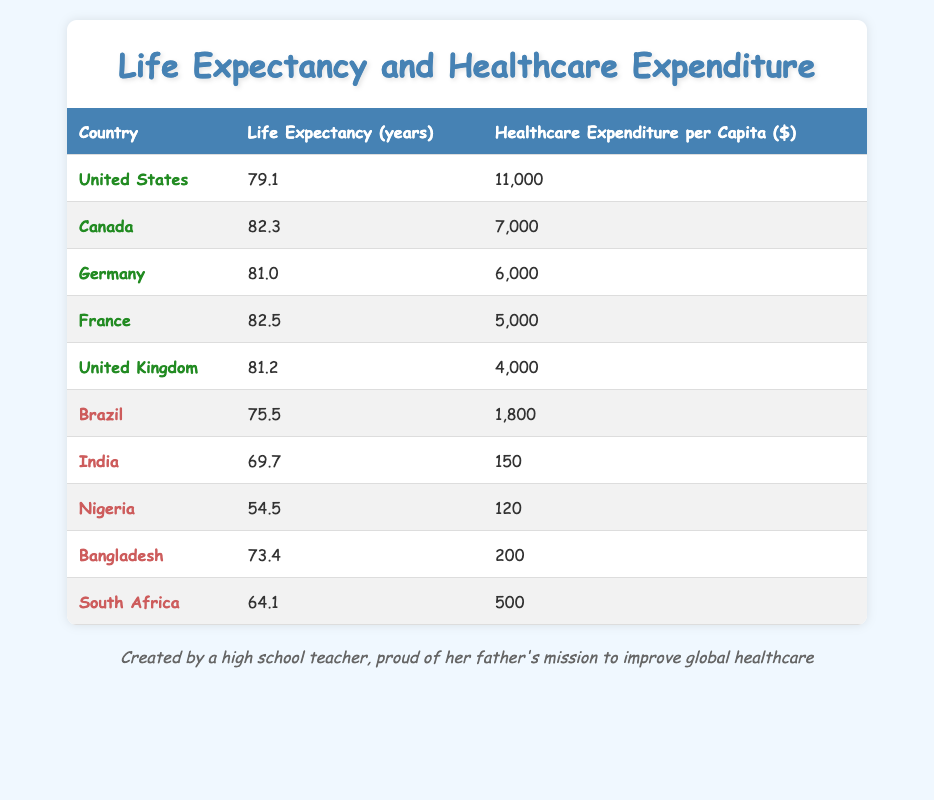What is the life expectancy of Canada? The table lists Canada as having a life expectancy of 82.3 years.
Answer: 82.3 Which country has the highest healthcare expenditure per capita? According to the table, the United States has the highest healthcare expenditure per capita at 11,000 dollars.
Answer: United States What is the average life expectancy of the developing countries listed? The life expectancies for the developing countries (Brazil, India, Nigeria, Bangladesh, South Africa) are 75.5, 69.7, 54.5, 73.4, and 64.1 respectively. Their total is 337.2, and the average is 337.2 divided by 5, which equals 67.44 years.
Answer: 67.44 Is it true that France has a higher life expectancy than Germany? The table shows France has a life expectancy of 82.5 years, while Germany's is 81.0 years, which confirms France's higher life expectancy.
Answer: Yes Which country has the lowest healthcare expenditure per capita? From the table, India has the lowest healthcare expenditure per capita at 150 dollars.
Answer: India What is the difference in life expectancy between the United States and Nigeria? The United States has a life expectancy of 79.1 years, while Nigeria's is 54.5 years. The difference is calculated by subtracting Nigeria's life expectancy from that of the United States: 79.1 - 54.5 = 24.6 years.
Answer: 24.6 How many countries have a life expectancy of over 80 years? The countries with over 80 years of life expectancy are Canada (82.3), France (82.5), and Germany (81.0). This makes a total of 3 countries.
Answer: 3 What percentage of the healthcare expenditure in the United States compared to that of the lowest (Nigeria)? The healthcare expenditure in the United States is 11,000 dollars and Nigeria's is 120 dollars. To find the percentage, divide 11,000 by 120 and multiply by 100, giving approximately 9166.67 percent.
Answer: 9166.67 What is the total healthcare expenditure per capita of the developed countries in the table? The developed countries and their expenditures are the United States (11,000), Canada (7,000), Germany (6,000), France (5,000), and United Kingdom (4,000). The total is 11,000 + 7,000 + 6,000 + 5,000 + 4,000 = 33,000 dollars.
Answer: 33,000 